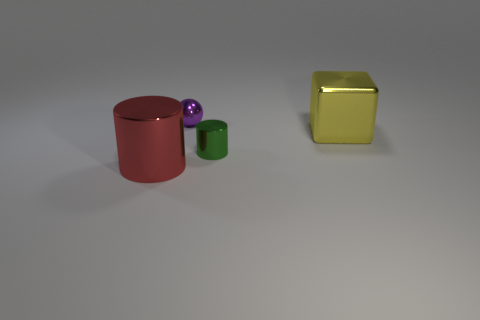Add 4 small purple matte spheres. How many objects exist? 8 Subtract 1 spheres. How many spheres are left? 0 Subtract all brown balls. Subtract all brown blocks. How many balls are left? 1 Subtract 0 green balls. How many objects are left? 4 Subtract all spheres. How many objects are left? 3 Subtract all purple cubes. How many brown cylinders are left? 0 Subtract all tiny balls. Subtract all large gray shiny balls. How many objects are left? 3 Add 1 large red metallic cylinders. How many large red metallic cylinders are left? 2 Add 3 big cubes. How many big cubes exist? 4 